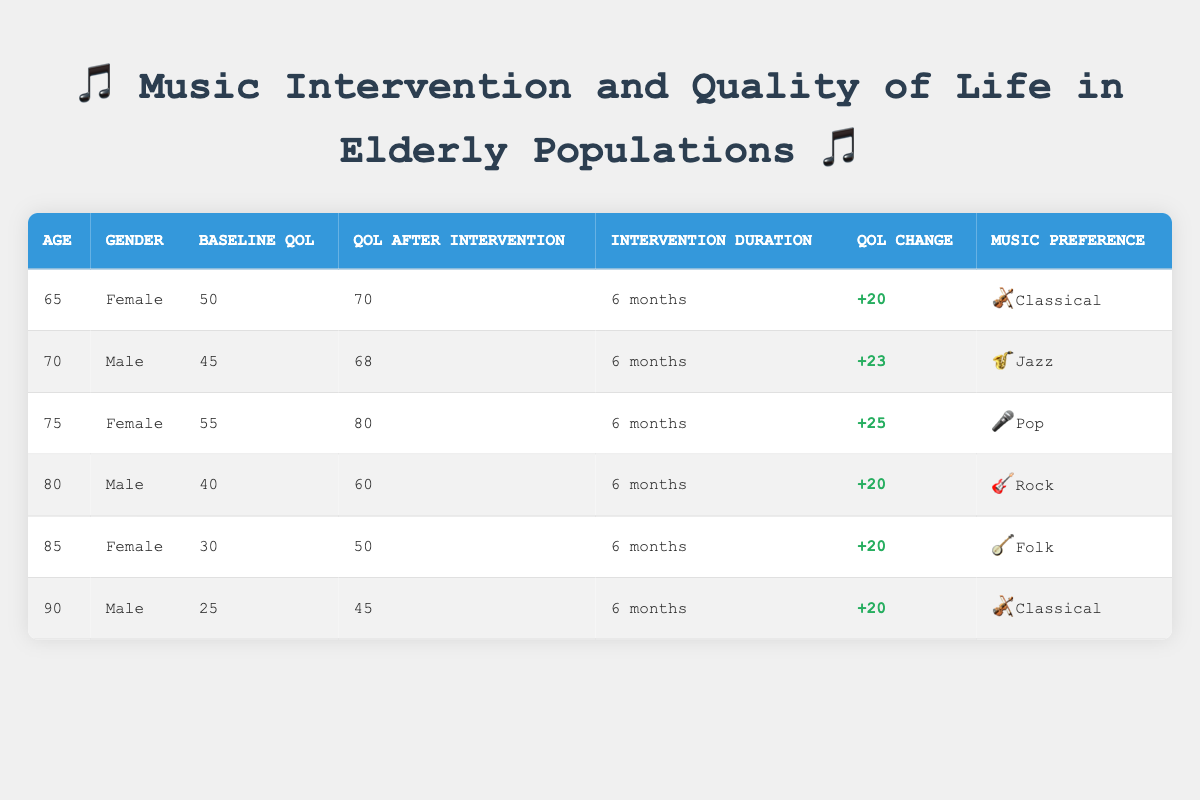What was the highest quality of life after the intervention? In the table, we look for the "QoL After Intervention" values for each individual, which are 70, 68, 80, 60, 50, and 45. The maximum value among them is 80.
Answer: 80 What change in quality of life did the 75-year-old female experience? By referring to the row for the 75-year-old female, the "QoL Change" is listed as +25.
Answer: 25 Is there a male participant who preferred Classical music? Looking at the entries for males in the table, the 90-year-old male has a music preference of Classical, indicating there is a male participant who preferred this genre.
Answer: Yes What is the average baseline quality of life for all participants? To calculate the average, we first sum the "Baseline QoL" values: (50 + 45 + 55 + 40 + 30 + 25) = 245. There are 6 participants, so the average is 245 / 6 = 40.833, which we round to 41.
Answer: 41 What was the total improvement in quality of life for all participants combined? We sum the "QoL Change" values: (20 + 23 + 25 + 20 + 20 + 20) = 128. This total reflects the overall positive change in quality of life due to the music intervention.
Answer: 128 How many participants showed a change in quality of life of 20 or more? We look at the "QoL Change" values in the table: 20, 23, 25, 20, 20, 20. All 6 participants had a change of 20 or more, thus they all qualify.
Answer: 6 What music preferences do participants aged 80 and above have? The relevant rows for those aged 80 and above are for the 80-year-old male (Rock) and the 85-year-old female (Folk) and the 90-year-old male (Classical). Therefore, their preferences are Rock, Folk, and Classical.
Answer: Rock, Folk, Classical Which age group showed the highest increase in quality of life? By assessing the "QoL Change" values, we find the 75-year-old female with a +25 increase, which is the highest compared to the others (+20, +20, +20, +23). Thus, the 75-year-old female showed the largest increase.
Answer: 75-year-old female 